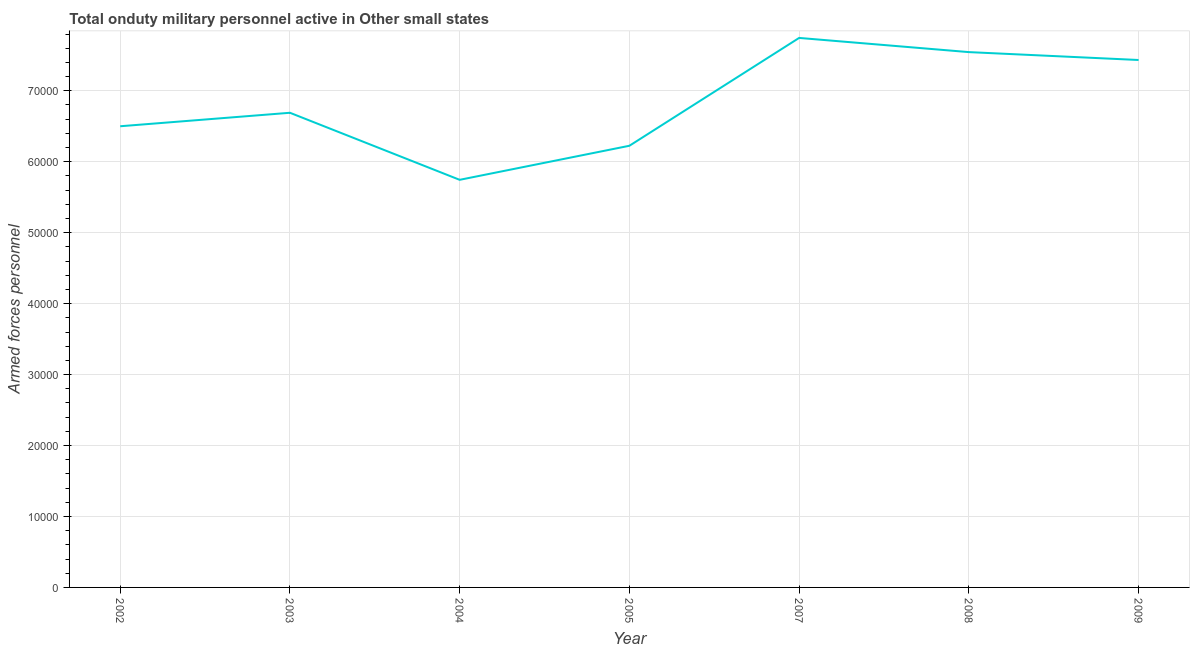What is the number of armed forces personnel in 2009?
Make the answer very short. 7.43e+04. Across all years, what is the maximum number of armed forces personnel?
Keep it short and to the point. 7.74e+04. Across all years, what is the minimum number of armed forces personnel?
Keep it short and to the point. 5.74e+04. What is the sum of the number of armed forces personnel?
Make the answer very short. 4.79e+05. What is the difference between the number of armed forces personnel in 2004 and 2005?
Offer a terse response. -4800. What is the average number of armed forces personnel per year?
Your response must be concise. 6.84e+04. What is the median number of armed forces personnel?
Your response must be concise. 6.69e+04. Do a majority of the years between 2003 and 2002 (inclusive) have number of armed forces personnel greater than 4000 ?
Provide a short and direct response. No. What is the ratio of the number of armed forces personnel in 2002 to that in 2003?
Provide a short and direct response. 0.97. Is the number of armed forces personnel in 2007 less than that in 2008?
Give a very brief answer. No. Is the difference between the number of armed forces personnel in 2007 and 2009 greater than the difference between any two years?
Provide a short and direct response. No. Is the sum of the number of armed forces personnel in 2003 and 2008 greater than the maximum number of armed forces personnel across all years?
Your answer should be compact. Yes. What is the difference between the highest and the lowest number of armed forces personnel?
Give a very brief answer. 2.00e+04. In how many years, is the number of armed forces personnel greater than the average number of armed forces personnel taken over all years?
Ensure brevity in your answer.  3. Does the number of armed forces personnel monotonically increase over the years?
Provide a succinct answer. No. How many lines are there?
Your answer should be very brief. 1. How many years are there in the graph?
Your response must be concise. 7. What is the difference between two consecutive major ticks on the Y-axis?
Make the answer very short. 10000. Are the values on the major ticks of Y-axis written in scientific E-notation?
Keep it short and to the point. No. What is the title of the graph?
Provide a succinct answer. Total onduty military personnel active in Other small states. What is the label or title of the Y-axis?
Provide a succinct answer. Armed forces personnel. What is the Armed forces personnel of 2002?
Offer a terse response. 6.50e+04. What is the Armed forces personnel in 2003?
Your response must be concise. 6.69e+04. What is the Armed forces personnel of 2004?
Provide a short and direct response. 5.74e+04. What is the Armed forces personnel of 2005?
Make the answer very short. 6.22e+04. What is the Armed forces personnel of 2007?
Provide a succinct answer. 7.74e+04. What is the Armed forces personnel of 2008?
Keep it short and to the point. 7.54e+04. What is the Armed forces personnel of 2009?
Make the answer very short. 7.43e+04. What is the difference between the Armed forces personnel in 2002 and 2003?
Your answer should be compact. -1900. What is the difference between the Armed forces personnel in 2002 and 2004?
Offer a very short reply. 7550. What is the difference between the Armed forces personnel in 2002 and 2005?
Provide a short and direct response. 2750. What is the difference between the Armed forces personnel in 2002 and 2007?
Your answer should be compact. -1.24e+04. What is the difference between the Armed forces personnel in 2002 and 2008?
Provide a short and direct response. -1.04e+04. What is the difference between the Armed forces personnel in 2002 and 2009?
Offer a very short reply. -9337. What is the difference between the Armed forces personnel in 2003 and 2004?
Your answer should be very brief. 9450. What is the difference between the Armed forces personnel in 2003 and 2005?
Your answer should be compact. 4650. What is the difference between the Armed forces personnel in 2003 and 2007?
Provide a short and direct response. -1.06e+04. What is the difference between the Armed forces personnel in 2003 and 2008?
Give a very brief answer. -8550. What is the difference between the Armed forces personnel in 2003 and 2009?
Ensure brevity in your answer.  -7437. What is the difference between the Armed forces personnel in 2004 and 2005?
Provide a short and direct response. -4800. What is the difference between the Armed forces personnel in 2004 and 2007?
Offer a very short reply. -2.00e+04. What is the difference between the Armed forces personnel in 2004 and 2008?
Give a very brief answer. -1.80e+04. What is the difference between the Armed forces personnel in 2004 and 2009?
Offer a terse response. -1.69e+04. What is the difference between the Armed forces personnel in 2005 and 2007?
Give a very brief answer. -1.52e+04. What is the difference between the Armed forces personnel in 2005 and 2008?
Ensure brevity in your answer.  -1.32e+04. What is the difference between the Armed forces personnel in 2005 and 2009?
Make the answer very short. -1.21e+04. What is the difference between the Armed forces personnel in 2007 and 2008?
Provide a succinct answer. 2000. What is the difference between the Armed forces personnel in 2007 and 2009?
Offer a terse response. 3113. What is the difference between the Armed forces personnel in 2008 and 2009?
Make the answer very short. 1113. What is the ratio of the Armed forces personnel in 2002 to that in 2003?
Your response must be concise. 0.97. What is the ratio of the Armed forces personnel in 2002 to that in 2004?
Provide a short and direct response. 1.13. What is the ratio of the Armed forces personnel in 2002 to that in 2005?
Keep it short and to the point. 1.04. What is the ratio of the Armed forces personnel in 2002 to that in 2007?
Your response must be concise. 0.84. What is the ratio of the Armed forces personnel in 2002 to that in 2008?
Your response must be concise. 0.86. What is the ratio of the Armed forces personnel in 2002 to that in 2009?
Your answer should be very brief. 0.87. What is the ratio of the Armed forces personnel in 2003 to that in 2004?
Ensure brevity in your answer.  1.16. What is the ratio of the Armed forces personnel in 2003 to that in 2005?
Offer a terse response. 1.07. What is the ratio of the Armed forces personnel in 2003 to that in 2007?
Keep it short and to the point. 0.86. What is the ratio of the Armed forces personnel in 2003 to that in 2008?
Keep it short and to the point. 0.89. What is the ratio of the Armed forces personnel in 2003 to that in 2009?
Offer a terse response. 0.9. What is the ratio of the Armed forces personnel in 2004 to that in 2005?
Give a very brief answer. 0.92. What is the ratio of the Armed forces personnel in 2004 to that in 2007?
Keep it short and to the point. 0.74. What is the ratio of the Armed forces personnel in 2004 to that in 2008?
Keep it short and to the point. 0.76. What is the ratio of the Armed forces personnel in 2004 to that in 2009?
Offer a very short reply. 0.77. What is the ratio of the Armed forces personnel in 2005 to that in 2007?
Your answer should be very brief. 0.8. What is the ratio of the Armed forces personnel in 2005 to that in 2008?
Your response must be concise. 0.82. What is the ratio of the Armed forces personnel in 2005 to that in 2009?
Your answer should be very brief. 0.84. What is the ratio of the Armed forces personnel in 2007 to that in 2009?
Offer a very short reply. 1.04. What is the ratio of the Armed forces personnel in 2008 to that in 2009?
Offer a very short reply. 1.01. 